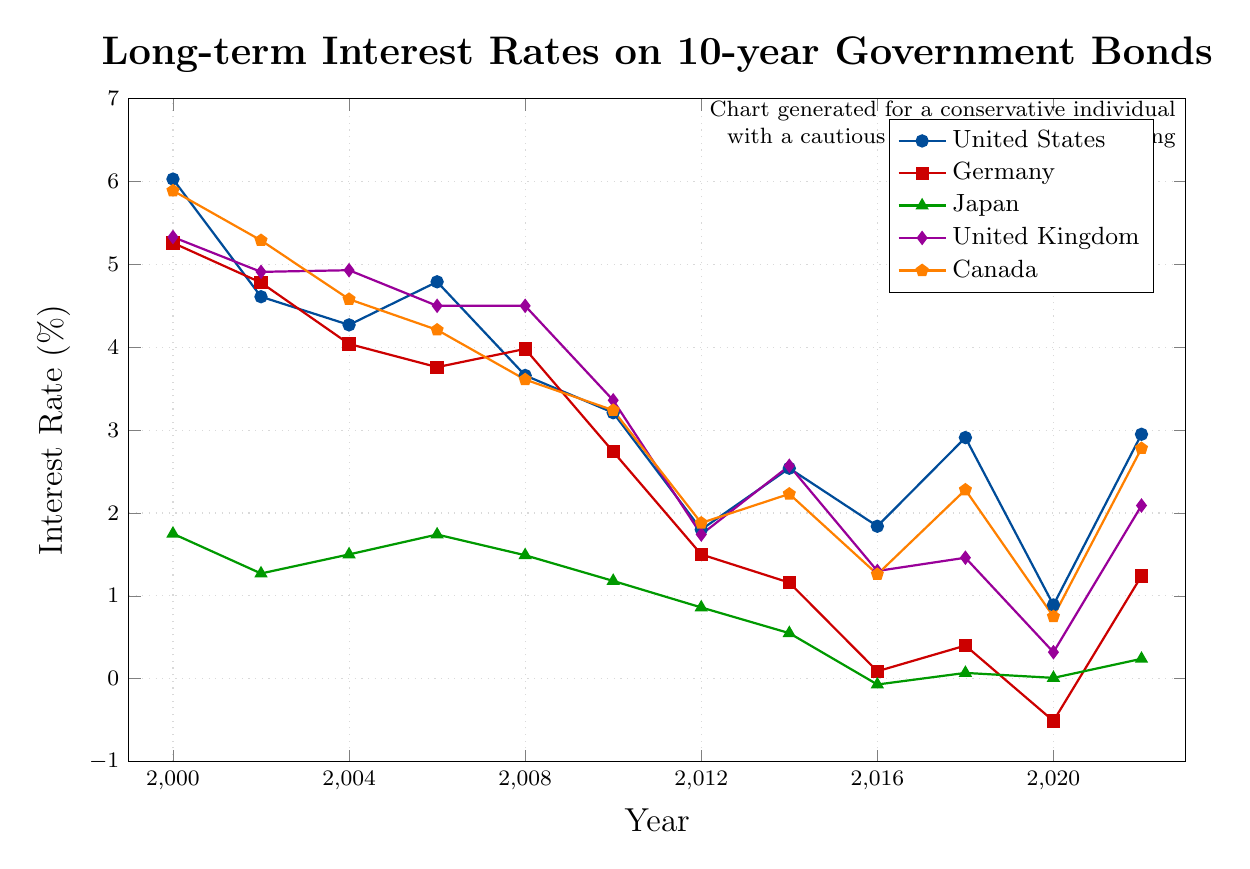Which country had the highest interest rate in 2000? In 2000, looking at the highest points on the y-axis, the United States had the highest interest rate at 6.03%.
Answer: United States Which country had an interest rate of -0.51% in 2020? In 2020, Germany had an interest rate of -0.51%, as indicated by the negative value marked with a square.
Answer: Germany How did the interest rates for Japan change from 2016 to 2018? In 2016, Japan had an interest rate of -0.07%, and in 2018 it was 0.07%. This shows an increase of 0.14%.
Answer: Increased by 0.14% Which year did the United Kingdom have its lowest interest rate? The lowest point for the United Kingdom occurred in 2020 with an interest rate of 0.32%, easily identified by the lowest diamond marker on the plot.
Answer: 2020 Compare the interest rate trends for the United States and Canada between 2012 and 2014. In 2012, the US had an interest rate of 1.80% and Canada had 1.88%. In 2014, the US increased to 2.54%, while Canada increased to 2.23%. Both countries experienced an increase, but the US had a larger increase of 0.74% compared to Canada's 0.35%.
Answer: US had a larger increase In which year did Japan have a negative interest rate? Japan had a negative interest rate in 2016, indicated by the triangle marker below zero.
Answer: 2016 Which country had the most stable interest rates from 2000 to 2022? By observing the plot, Japan shows less fluctuation in its interest rates over the years compared to other countries, maintaining rates mostly between -0.07% and 1.75%.
Answer: Japan Compare the interest rates for Germany and the United Kingdom in 2008. In 2008, Germany had an interest rate of 3.98%, and the United Kingdom had 4.50%. The United Kingdom's interest rate was higher by 0.52%.
Answer: United Kingdom What is the average interest rate for Germany from 2000 to 2022? To find the average, sum all the interest rates for Germany from 2000 to 2022 and divide by the number of data points: (5.26 + 4.78 + 4.04 + 3.76 + 3.98 + 2.74 + 1.50 + 1.16 + 0.09 + 0.40 - 0.51 + 1.24) / 12 = 23.44 / 12 = 1.95%.
Answer: 1.95% 